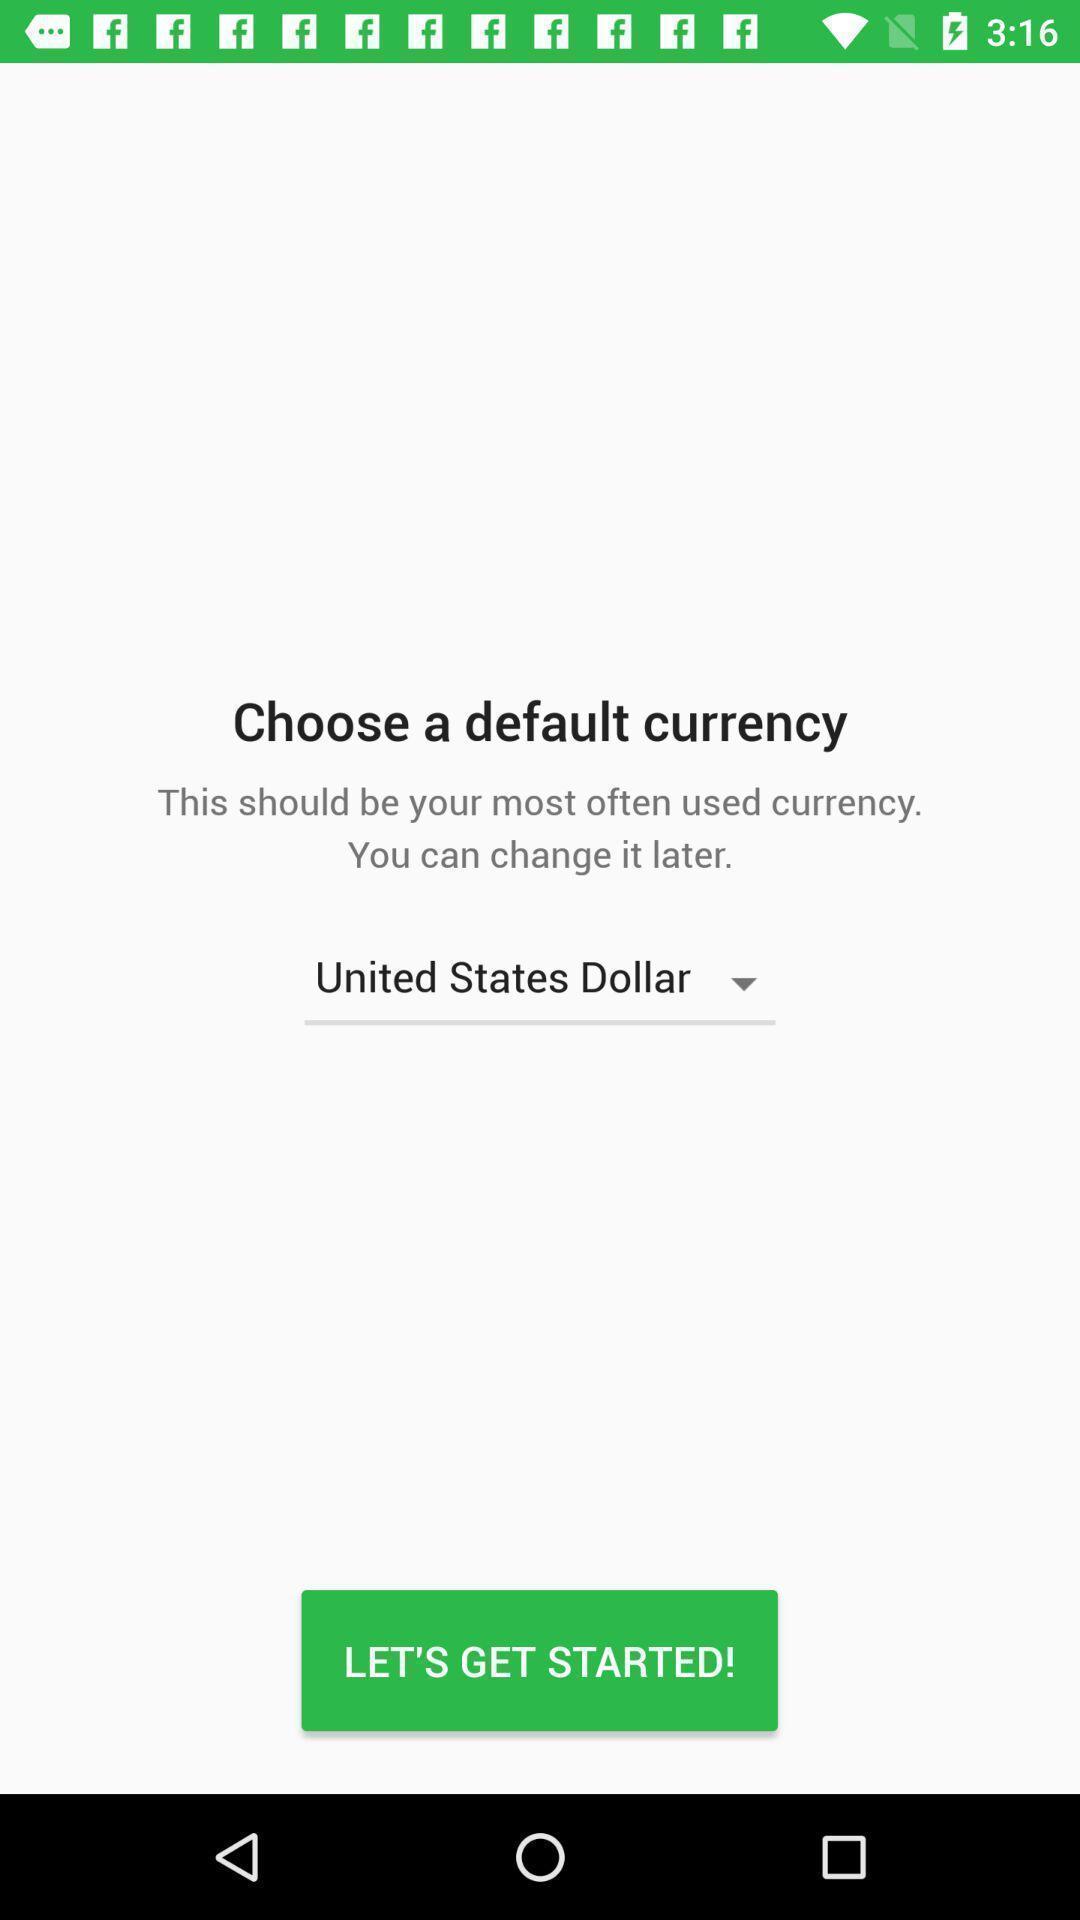Tell me what you see in this picture. Starting page for an application. 